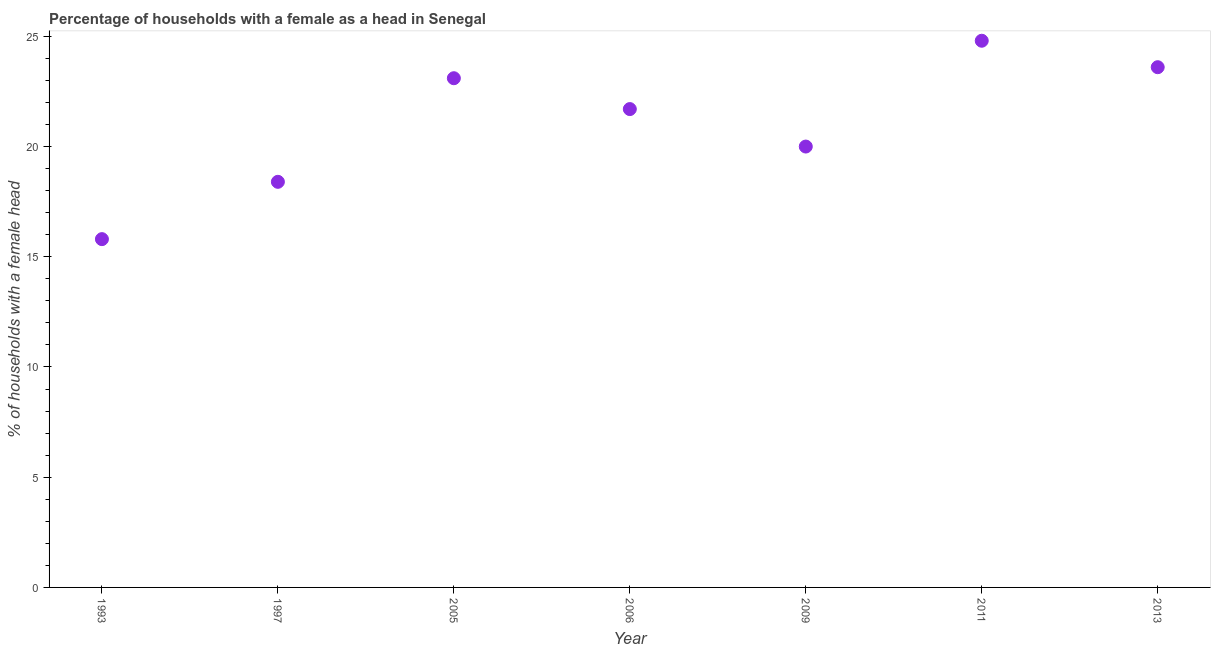Across all years, what is the maximum number of female supervised households?
Offer a very short reply. 24.8. Across all years, what is the minimum number of female supervised households?
Your answer should be compact. 15.8. In which year was the number of female supervised households maximum?
Provide a succinct answer. 2011. In which year was the number of female supervised households minimum?
Give a very brief answer. 1993. What is the sum of the number of female supervised households?
Offer a very short reply. 147.4. What is the difference between the number of female supervised households in 2006 and 2011?
Offer a very short reply. -3.1. What is the average number of female supervised households per year?
Make the answer very short. 21.06. What is the median number of female supervised households?
Provide a short and direct response. 21.7. What is the ratio of the number of female supervised households in 1997 to that in 2013?
Provide a succinct answer. 0.78. Is the number of female supervised households in 1997 less than that in 2013?
Provide a succinct answer. Yes. Is the difference between the number of female supervised households in 2009 and 2013 greater than the difference between any two years?
Offer a very short reply. No. What is the difference between the highest and the second highest number of female supervised households?
Make the answer very short. 1.2. In how many years, is the number of female supervised households greater than the average number of female supervised households taken over all years?
Your answer should be compact. 4. Does the number of female supervised households monotonically increase over the years?
Your response must be concise. No. What is the difference between two consecutive major ticks on the Y-axis?
Ensure brevity in your answer.  5. Does the graph contain any zero values?
Ensure brevity in your answer.  No. What is the title of the graph?
Keep it short and to the point. Percentage of households with a female as a head in Senegal. What is the label or title of the X-axis?
Give a very brief answer. Year. What is the label or title of the Y-axis?
Your answer should be compact. % of households with a female head. What is the % of households with a female head in 2005?
Give a very brief answer. 23.1. What is the % of households with a female head in 2006?
Offer a very short reply. 21.7. What is the % of households with a female head in 2011?
Ensure brevity in your answer.  24.8. What is the % of households with a female head in 2013?
Your response must be concise. 23.6. What is the difference between the % of households with a female head in 1993 and 2005?
Your response must be concise. -7.3. What is the difference between the % of households with a female head in 1993 and 2006?
Make the answer very short. -5.9. What is the difference between the % of households with a female head in 1993 and 2009?
Provide a succinct answer. -4.2. What is the difference between the % of households with a female head in 1997 and 2006?
Your answer should be compact. -3.3. What is the difference between the % of households with a female head in 2005 and 2006?
Provide a succinct answer. 1.4. What is the difference between the % of households with a female head in 2009 and 2011?
Keep it short and to the point. -4.8. What is the ratio of the % of households with a female head in 1993 to that in 1997?
Make the answer very short. 0.86. What is the ratio of the % of households with a female head in 1993 to that in 2005?
Ensure brevity in your answer.  0.68. What is the ratio of the % of households with a female head in 1993 to that in 2006?
Offer a terse response. 0.73. What is the ratio of the % of households with a female head in 1993 to that in 2009?
Provide a succinct answer. 0.79. What is the ratio of the % of households with a female head in 1993 to that in 2011?
Your answer should be compact. 0.64. What is the ratio of the % of households with a female head in 1993 to that in 2013?
Make the answer very short. 0.67. What is the ratio of the % of households with a female head in 1997 to that in 2005?
Your answer should be very brief. 0.8. What is the ratio of the % of households with a female head in 1997 to that in 2006?
Your response must be concise. 0.85. What is the ratio of the % of households with a female head in 1997 to that in 2009?
Offer a very short reply. 0.92. What is the ratio of the % of households with a female head in 1997 to that in 2011?
Provide a short and direct response. 0.74. What is the ratio of the % of households with a female head in 1997 to that in 2013?
Offer a terse response. 0.78. What is the ratio of the % of households with a female head in 2005 to that in 2006?
Provide a succinct answer. 1.06. What is the ratio of the % of households with a female head in 2005 to that in 2009?
Give a very brief answer. 1.16. What is the ratio of the % of households with a female head in 2006 to that in 2009?
Provide a short and direct response. 1.08. What is the ratio of the % of households with a female head in 2006 to that in 2011?
Give a very brief answer. 0.88. What is the ratio of the % of households with a female head in 2006 to that in 2013?
Provide a succinct answer. 0.92. What is the ratio of the % of households with a female head in 2009 to that in 2011?
Your answer should be compact. 0.81. What is the ratio of the % of households with a female head in 2009 to that in 2013?
Your answer should be very brief. 0.85. What is the ratio of the % of households with a female head in 2011 to that in 2013?
Offer a terse response. 1.05. 